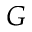<formula> <loc_0><loc_0><loc_500><loc_500>G</formula> 